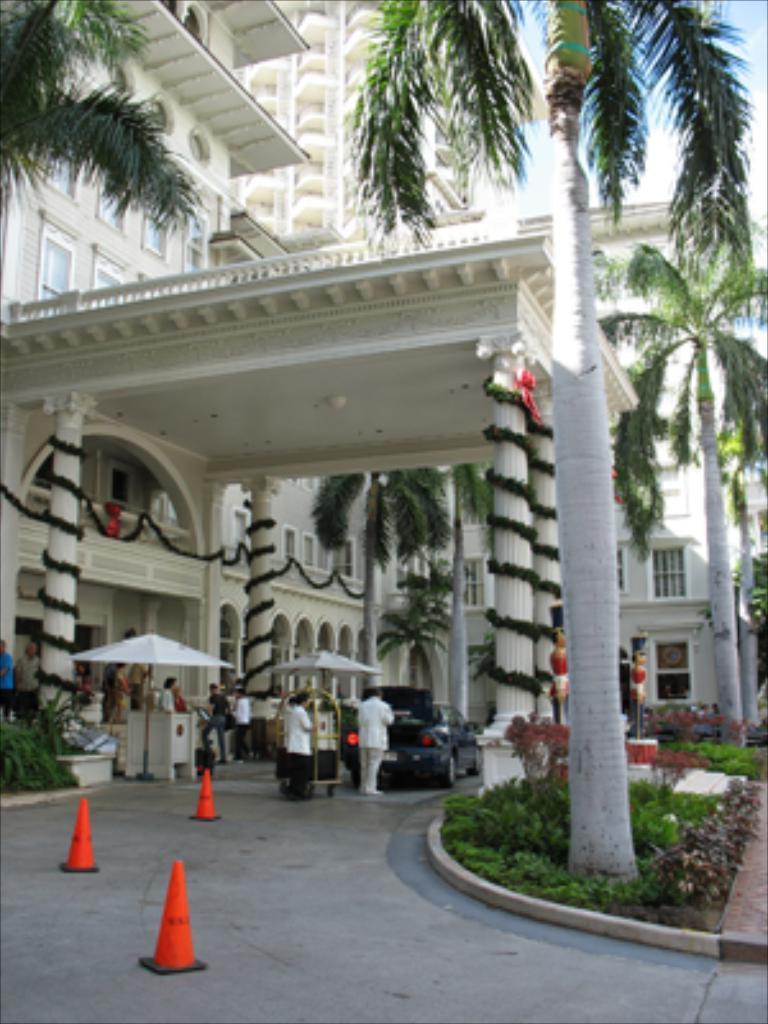What type of structures can be seen in the image? There are buildings in the image. What natural elements are present in the image? There are trees and plants in the image. What part of the natural environment is visible in the image? The sky is visible in the image. Who or what can be seen in the image? There are people in the image. What architectural features can be seen in the image? There are windows in the image. What mode of transportation is present in the image? There is a car in the image. What safety equipment is present in the image? There are traffic cones in the image. What type of flower is depicted in the image? There is no flower present in the image. What is the belief system of the people in the image? The image does not provide any information about the belief system of the people in the image. 